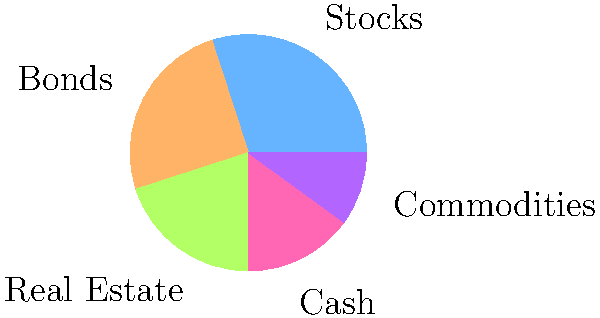As a rookie investment banker, you're analyzing a client's portfolio. The pie chart shows their current asset allocation. If the client wants to increase their exposure to fixed income securities, which slice of the pie should grow? To answer this question, we need to follow these steps:

1. Understand what fixed income securities are:
   Fixed income securities are investment vehicles that provide regular income in the form of interest payments. They are typically less risky than stocks but offer lower potential returns.

2. Identify which asset class in the pie chart represents fixed income securities:
   In this asset allocation pie chart, "Bonds" represent fixed income securities.

3. Locate the "Bonds" slice in the pie chart:
   The "Bonds" slice is colored orange and represents 25% of the total portfolio.

4. Conclude:
   If the client wants to increase their exposure to fixed income securities, they should increase their allocation to bonds. This means the "Bonds" slice of the pie should grow.
Answer: Bonds 